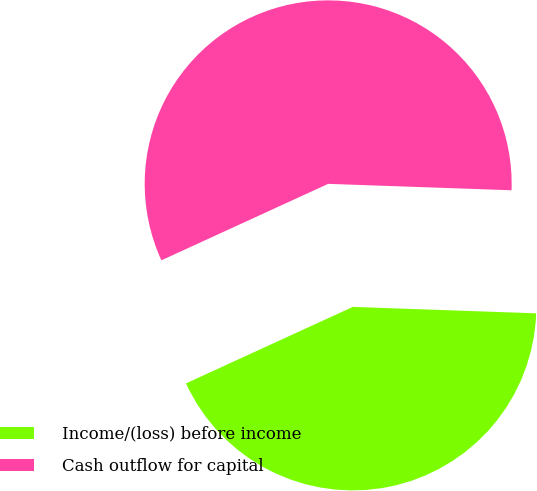Convert chart. <chart><loc_0><loc_0><loc_500><loc_500><pie_chart><fcel>Income/(loss) before income<fcel>Cash outflow for capital<nl><fcel>42.6%<fcel>57.4%<nl></chart> 